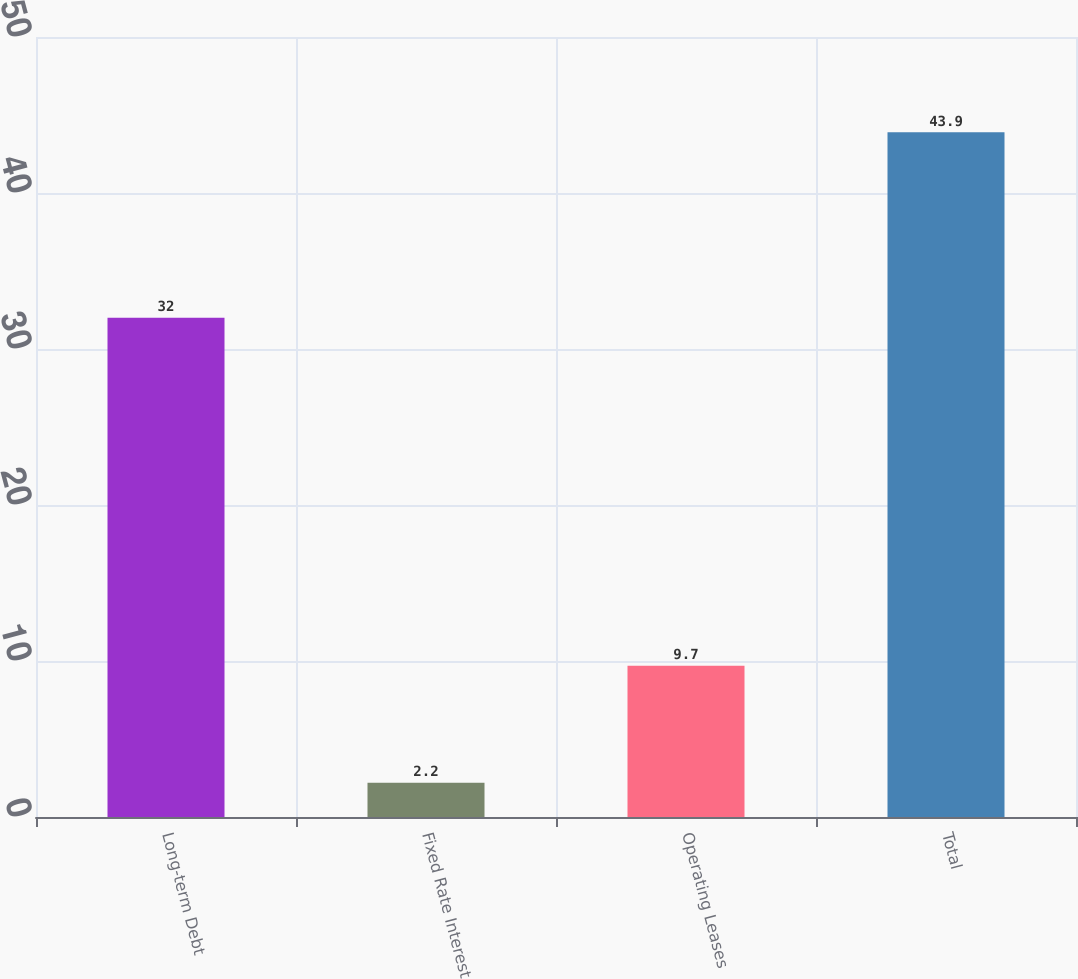Convert chart to OTSL. <chart><loc_0><loc_0><loc_500><loc_500><bar_chart><fcel>Long-term Debt<fcel>Fixed Rate Interest<fcel>Operating Leases<fcel>Total<nl><fcel>32<fcel>2.2<fcel>9.7<fcel>43.9<nl></chart> 